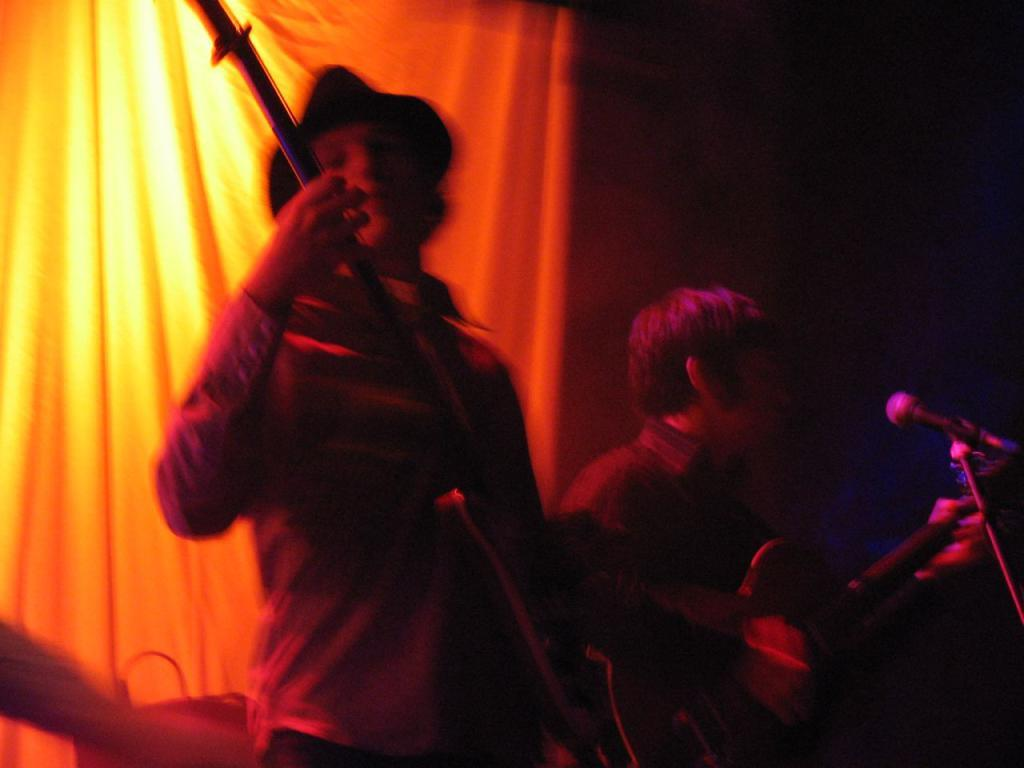What is the person wearing in the image? The person is wearing a hat. What object is the person holding in the image? The person is holding a guitar. Can you describe the person's position in relation to the microphone? The person is holding the guitar in front of a microphone. What type of apparatus is the person using to harness the wind in the image? There is no apparatus for harnessing wind present in the image. What role does the person play in the image, as the lead in a band or performance? The provided facts do not indicate the person's role or position in a band or performance. 